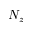Convert formula to latex. <formula><loc_0><loc_0><loc_500><loc_500>N _ { z }</formula> 